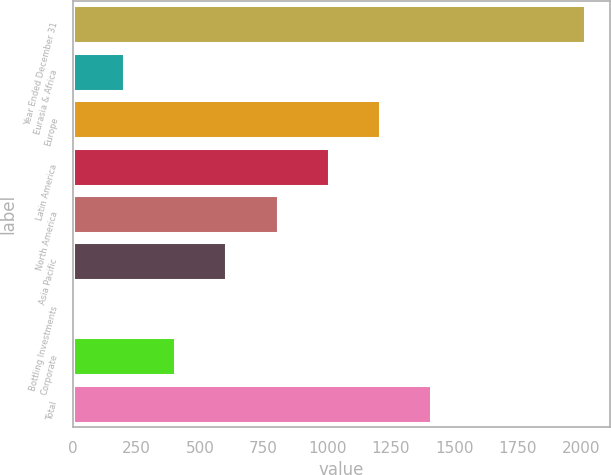Convert chart. <chart><loc_0><loc_0><loc_500><loc_500><bar_chart><fcel>Year Ended December 31<fcel>Eurasia & Africa<fcel>Europe<fcel>Latin America<fcel>North America<fcel>Asia Pacific<fcel>Bottling Investments<fcel>Corporate<fcel>Total<nl><fcel>2012<fcel>202.37<fcel>1207.72<fcel>1006.65<fcel>805.58<fcel>604.51<fcel>1.3<fcel>403.44<fcel>1408.79<nl></chart> 